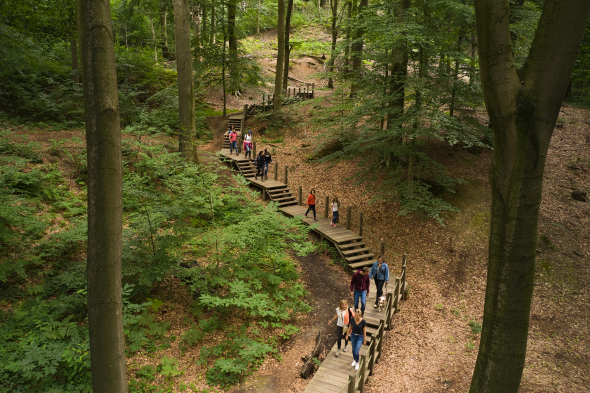Where do you think this is? Give 5 propositions It looks like a hiking trail in a forest. The trees are tall and green, and the path is made of wood. There are people walking on the path, and they are all wearing casual clothes. It is a sunny day, and the sun is shining through the trees. The forest is dense, and the trees are close together. The path is winding, and it looks like it leads to somewhere.

Here are 5 propositions:

1. The forest is located in a national park.
2. The forest is located in a state park.
3. The forest is located in a county park.
4. The forest is located in a city park.
5. The forest is located on private property. 